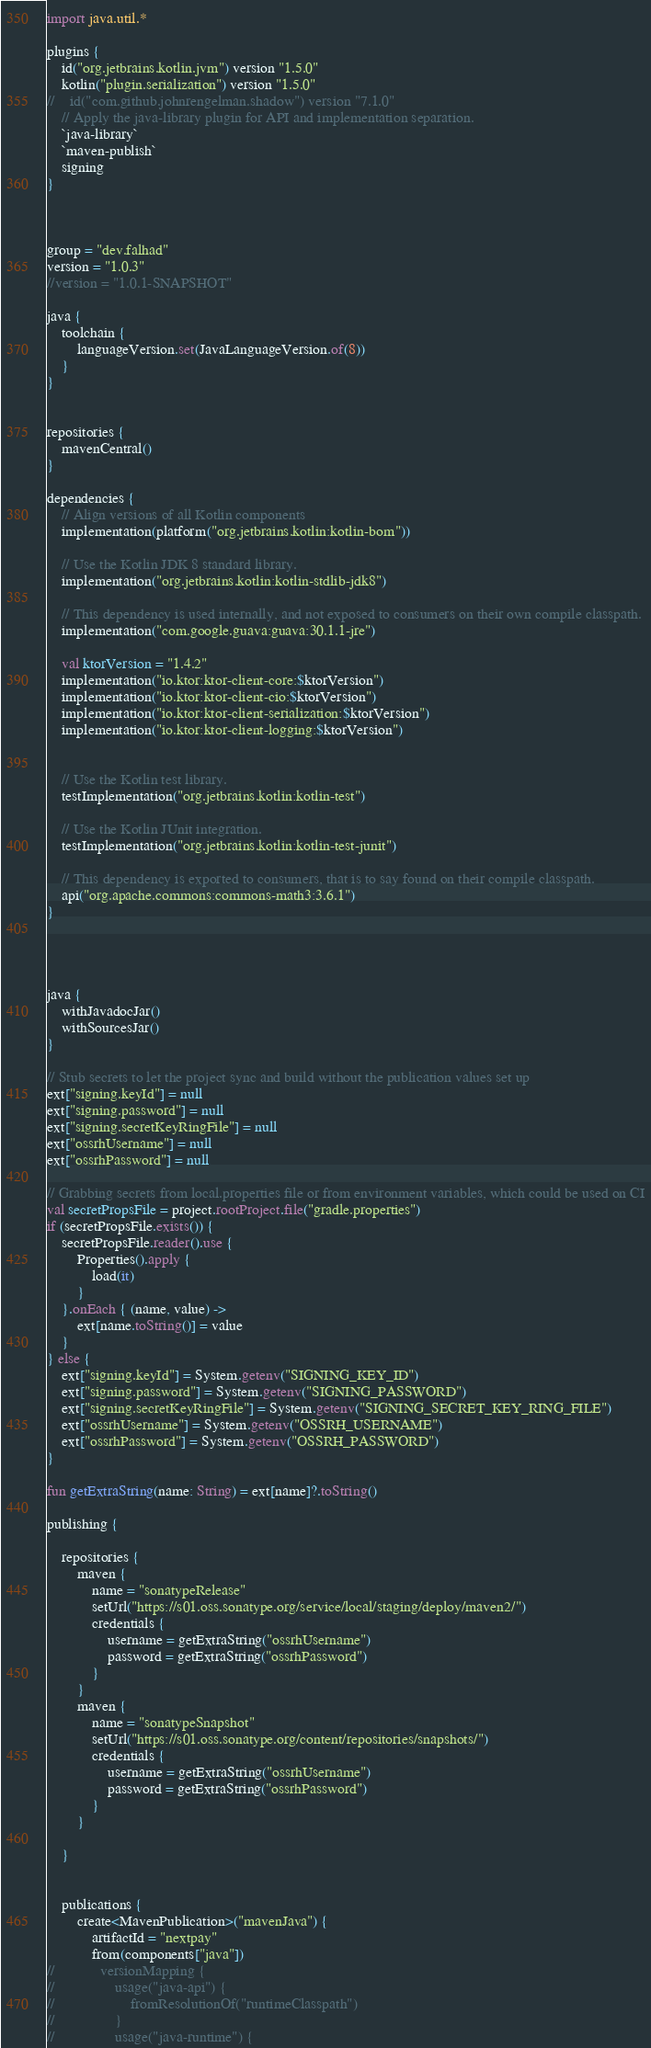Convert code to text. <code><loc_0><loc_0><loc_500><loc_500><_Kotlin_>
import java.util.*

plugins {
    id("org.jetbrains.kotlin.jvm") version "1.5.0"
    kotlin("plugin.serialization") version "1.5.0"
//    id("com.github.johnrengelman.shadow") version "7.1.0"
    // Apply the java-library plugin for API and implementation separation.
    `java-library`
    `maven-publish`
    signing
}



group = "dev.falhad"
version = "1.0.3"
//version = "1.0.1-SNAPSHOT"

java {
    toolchain {
        languageVersion.set(JavaLanguageVersion.of(8))
    }
}


repositories {
    mavenCentral()
}

dependencies {
    // Align versions of all Kotlin components
    implementation(platform("org.jetbrains.kotlin:kotlin-bom"))

    // Use the Kotlin JDK 8 standard library.
    implementation("org.jetbrains.kotlin:kotlin-stdlib-jdk8")

    // This dependency is used internally, and not exposed to consumers on their own compile classpath.
    implementation("com.google.guava:guava:30.1.1-jre")

    val ktorVersion = "1.4.2"
    implementation("io.ktor:ktor-client-core:$ktorVersion")
    implementation("io.ktor:ktor-client-cio:$ktorVersion")
    implementation("io.ktor:ktor-client-serialization:$ktorVersion")
    implementation("io.ktor:ktor-client-logging:$ktorVersion")


    // Use the Kotlin test library.
    testImplementation("org.jetbrains.kotlin:kotlin-test")

    // Use the Kotlin JUnit integration.
    testImplementation("org.jetbrains.kotlin:kotlin-test-junit")

    // This dependency is exported to consumers, that is to say found on their compile classpath.
    api("org.apache.commons:commons-math3:3.6.1")
}




java {
    withJavadocJar()
    withSourcesJar()
}

// Stub secrets to let the project sync and build without the publication values set up
ext["signing.keyId"] = null
ext["signing.password"] = null
ext["signing.secretKeyRingFile"] = null
ext["ossrhUsername"] = null
ext["ossrhPassword"] = null

// Grabbing secrets from local.properties file or from environment variables, which could be used on CI
val secretPropsFile = project.rootProject.file("gradle.properties")
if (secretPropsFile.exists()) {
    secretPropsFile.reader().use {
        Properties().apply {
            load(it)
        }
    }.onEach { (name, value) ->
        ext[name.toString()] = value
    }
} else {
    ext["signing.keyId"] = System.getenv("SIGNING_KEY_ID")
    ext["signing.password"] = System.getenv("SIGNING_PASSWORD")
    ext["signing.secretKeyRingFile"] = System.getenv("SIGNING_SECRET_KEY_RING_FILE")
    ext["ossrhUsername"] = System.getenv("OSSRH_USERNAME")
    ext["ossrhPassword"] = System.getenv("OSSRH_PASSWORD")
}

fun getExtraString(name: String) = ext[name]?.toString()

publishing {

    repositories {
        maven {
            name = "sonatypeRelease"
            setUrl("https://s01.oss.sonatype.org/service/local/staging/deploy/maven2/")
            credentials {
                username = getExtraString("ossrhUsername")
                password = getExtraString("ossrhPassword")
            }
        }
        maven {
            name = "sonatypeSnapshot"
            setUrl("https://s01.oss.sonatype.org/content/repositories/snapshots/")
            credentials {
                username = getExtraString("ossrhUsername")
                password = getExtraString("ossrhPassword")
            }
        }

    }


    publications {
        create<MavenPublication>("mavenJava") {
            artifactId = "nextpay"
            from(components["java"])
//            versionMapping {
//                usage("java-api") {
//                    fromResolutionOf("runtimeClasspath")
//                }
//                usage("java-runtime") {</code> 